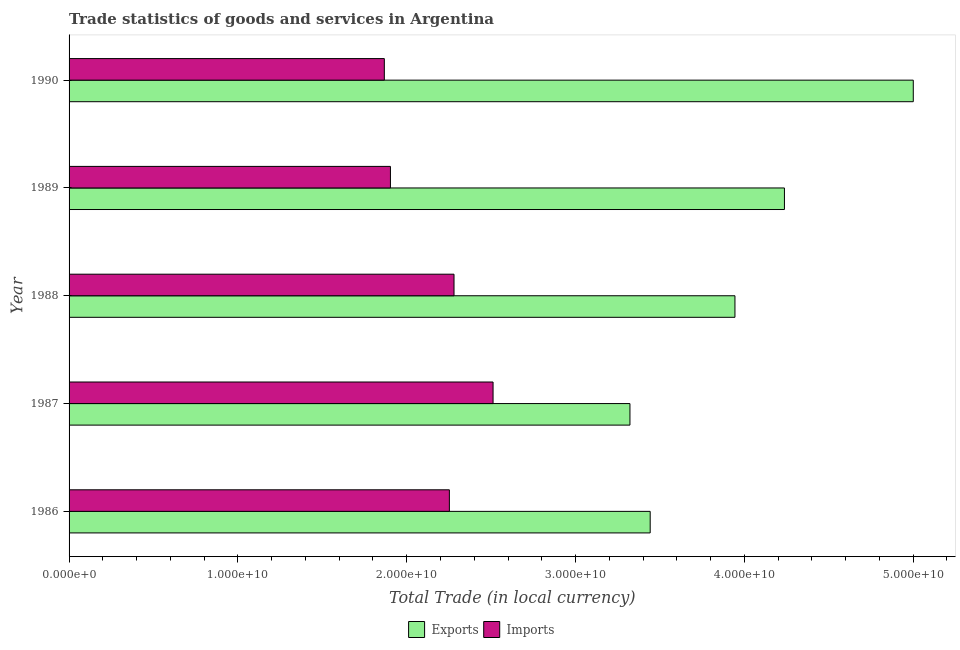How many groups of bars are there?
Provide a succinct answer. 5. Are the number of bars on each tick of the Y-axis equal?
Ensure brevity in your answer.  Yes. What is the export of goods and services in 1990?
Offer a terse response. 5.00e+1. Across all years, what is the maximum imports of goods and services?
Your response must be concise. 2.51e+1. Across all years, what is the minimum export of goods and services?
Your answer should be compact. 3.32e+1. In which year was the imports of goods and services maximum?
Keep it short and to the point. 1987. In which year was the export of goods and services minimum?
Your answer should be very brief. 1987. What is the total export of goods and services in the graph?
Keep it short and to the point. 1.99e+11. What is the difference between the export of goods and services in 1988 and that in 1989?
Your answer should be very brief. -2.93e+09. What is the difference between the export of goods and services in 1989 and the imports of goods and services in 1988?
Offer a terse response. 1.96e+1. What is the average imports of goods and services per year?
Provide a succinct answer. 2.16e+1. In the year 1986, what is the difference between the imports of goods and services and export of goods and services?
Provide a short and direct response. -1.19e+1. What is the ratio of the export of goods and services in 1988 to that in 1990?
Your answer should be very brief. 0.79. What is the difference between the highest and the second highest imports of goods and services?
Provide a short and direct response. 2.31e+09. What is the difference between the highest and the lowest export of goods and services?
Make the answer very short. 1.68e+1. In how many years, is the imports of goods and services greater than the average imports of goods and services taken over all years?
Offer a terse response. 3. Is the sum of the imports of goods and services in 1988 and 1990 greater than the maximum export of goods and services across all years?
Offer a very short reply. No. What does the 2nd bar from the top in 1986 represents?
Make the answer very short. Exports. What does the 1st bar from the bottom in 1986 represents?
Offer a very short reply. Exports. Are all the bars in the graph horizontal?
Your answer should be compact. Yes. Are the values on the major ticks of X-axis written in scientific E-notation?
Your answer should be very brief. Yes. Does the graph contain grids?
Offer a terse response. No. How many legend labels are there?
Your response must be concise. 2. How are the legend labels stacked?
Provide a succinct answer. Horizontal. What is the title of the graph?
Offer a terse response. Trade statistics of goods and services in Argentina. Does "Crop" appear as one of the legend labels in the graph?
Offer a very short reply. No. What is the label or title of the X-axis?
Keep it short and to the point. Total Trade (in local currency). What is the Total Trade (in local currency) of Exports in 1986?
Provide a short and direct response. 3.44e+1. What is the Total Trade (in local currency) of Imports in 1986?
Your answer should be compact. 2.25e+1. What is the Total Trade (in local currency) of Exports in 1987?
Your answer should be very brief. 3.32e+1. What is the Total Trade (in local currency) of Imports in 1987?
Offer a very short reply. 2.51e+1. What is the Total Trade (in local currency) of Exports in 1988?
Provide a short and direct response. 3.94e+1. What is the Total Trade (in local currency) in Imports in 1988?
Your answer should be compact. 2.28e+1. What is the Total Trade (in local currency) in Exports in 1989?
Keep it short and to the point. 4.24e+1. What is the Total Trade (in local currency) of Imports in 1989?
Make the answer very short. 1.90e+1. What is the Total Trade (in local currency) in Exports in 1990?
Provide a short and direct response. 5.00e+1. What is the Total Trade (in local currency) in Imports in 1990?
Your answer should be compact. 1.87e+1. Across all years, what is the maximum Total Trade (in local currency) of Exports?
Ensure brevity in your answer.  5.00e+1. Across all years, what is the maximum Total Trade (in local currency) of Imports?
Keep it short and to the point. 2.51e+1. Across all years, what is the minimum Total Trade (in local currency) in Exports?
Your answer should be compact. 3.32e+1. Across all years, what is the minimum Total Trade (in local currency) of Imports?
Ensure brevity in your answer.  1.87e+1. What is the total Total Trade (in local currency) of Exports in the graph?
Ensure brevity in your answer.  1.99e+11. What is the total Total Trade (in local currency) of Imports in the graph?
Keep it short and to the point. 1.08e+11. What is the difference between the Total Trade (in local currency) in Exports in 1986 and that in 1987?
Provide a short and direct response. 1.20e+09. What is the difference between the Total Trade (in local currency) in Imports in 1986 and that in 1987?
Offer a very short reply. -2.59e+09. What is the difference between the Total Trade (in local currency) of Exports in 1986 and that in 1988?
Your response must be concise. -5.02e+09. What is the difference between the Total Trade (in local currency) of Imports in 1986 and that in 1988?
Give a very brief answer. -2.75e+08. What is the difference between the Total Trade (in local currency) in Exports in 1986 and that in 1989?
Your answer should be compact. -7.95e+09. What is the difference between the Total Trade (in local currency) in Imports in 1986 and that in 1989?
Give a very brief answer. 3.49e+09. What is the difference between the Total Trade (in local currency) of Exports in 1986 and that in 1990?
Keep it short and to the point. -1.56e+1. What is the difference between the Total Trade (in local currency) of Imports in 1986 and that in 1990?
Provide a short and direct response. 3.85e+09. What is the difference between the Total Trade (in local currency) of Exports in 1987 and that in 1988?
Your answer should be very brief. -6.22e+09. What is the difference between the Total Trade (in local currency) of Imports in 1987 and that in 1988?
Your answer should be very brief. 2.31e+09. What is the difference between the Total Trade (in local currency) of Exports in 1987 and that in 1989?
Your answer should be very brief. -9.15e+09. What is the difference between the Total Trade (in local currency) of Imports in 1987 and that in 1989?
Keep it short and to the point. 6.08e+09. What is the difference between the Total Trade (in local currency) of Exports in 1987 and that in 1990?
Your response must be concise. -1.68e+1. What is the difference between the Total Trade (in local currency) of Imports in 1987 and that in 1990?
Ensure brevity in your answer.  6.44e+09. What is the difference between the Total Trade (in local currency) in Exports in 1988 and that in 1989?
Give a very brief answer. -2.93e+09. What is the difference between the Total Trade (in local currency) in Imports in 1988 and that in 1989?
Your response must be concise. 3.77e+09. What is the difference between the Total Trade (in local currency) of Exports in 1988 and that in 1990?
Offer a terse response. -1.06e+1. What is the difference between the Total Trade (in local currency) in Imports in 1988 and that in 1990?
Your answer should be very brief. 4.13e+09. What is the difference between the Total Trade (in local currency) of Exports in 1989 and that in 1990?
Your answer should be very brief. -7.63e+09. What is the difference between the Total Trade (in local currency) of Imports in 1989 and that in 1990?
Provide a succinct answer. 3.62e+08. What is the difference between the Total Trade (in local currency) in Exports in 1986 and the Total Trade (in local currency) in Imports in 1987?
Offer a very short reply. 9.31e+09. What is the difference between the Total Trade (in local currency) in Exports in 1986 and the Total Trade (in local currency) in Imports in 1988?
Provide a short and direct response. 1.16e+1. What is the difference between the Total Trade (in local currency) in Exports in 1986 and the Total Trade (in local currency) in Imports in 1989?
Offer a very short reply. 1.54e+1. What is the difference between the Total Trade (in local currency) in Exports in 1986 and the Total Trade (in local currency) in Imports in 1990?
Keep it short and to the point. 1.57e+1. What is the difference between the Total Trade (in local currency) of Exports in 1987 and the Total Trade (in local currency) of Imports in 1988?
Your answer should be very brief. 1.04e+1. What is the difference between the Total Trade (in local currency) in Exports in 1987 and the Total Trade (in local currency) in Imports in 1989?
Your answer should be compact. 1.42e+1. What is the difference between the Total Trade (in local currency) in Exports in 1987 and the Total Trade (in local currency) in Imports in 1990?
Your response must be concise. 1.45e+1. What is the difference between the Total Trade (in local currency) in Exports in 1988 and the Total Trade (in local currency) in Imports in 1989?
Keep it short and to the point. 2.04e+1. What is the difference between the Total Trade (in local currency) of Exports in 1988 and the Total Trade (in local currency) of Imports in 1990?
Ensure brevity in your answer.  2.08e+1. What is the difference between the Total Trade (in local currency) in Exports in 1989 and the Total Trade (in local currency) in Imports in 1990?
Keep it short and to the point. 2.37e+1. What is the average Total Trade (in local currency) in Exports per year?
Ensure brevity in your answer.  3.99e+1. What is the average Total Trade (in local currency) of Imports per year?
Keep it short and to the point. 2.16e+1. In the year 1986, what is the difference between the Total Trade (in local currency) in Exports and Total Trade (in local currency) in Imports?
Offer a very short reply. 1.19e+1. In the year 1987, what is the difference between the Total Trade (in local currency) of Exports and Total Trade (in local currency) of Imports?
Your answer should be very brief. 8.11e+09. In the year 1988, what is the difference between the Total Trade (in local currency) in Exports and Total Trade (in local currency) in Imports?
Provide a succinct answer. 1.66e+1. In the year 1989, what is the difference between the Total Trade (in local currency) in Exports and Total Trade (in local currency) in Imports?
Your answer should be compact. 2.33e+1. In the year 1990, what is the difference between the Total Trade (in local currency) of Exports and Total Trade (in local currency) of Imports?
Your answer should be very brief. 3.13e+1. What is the ratio of the Total Trade (in local currency) of Exports in 1986 to that in 1987?
Offer a terse response. 1.04. What is the ratio of the Total Trade (in local currency) in Imports in 1986 to that in 1987?
Give a very brief answer. 0.9. What is the ratio of the Total Trade (in local currency) of Exports in 1986 to that in 1988?
Offer a very short reply. 0.87. What is the ratio of the Total Trade (in local currency) in Imports in 1986 to that in 1988?
Ensure brevity in your answer.  0.99. What is the ratio of the Total Trade (in local currency) of Exports in 1986 to that in 1989?
Your answer should be very brief. 0.81. What is the ratio of the Total Trade (in local currency) of Imports in 1986 to that in 1989?
Your answer should be very brief. 1.18. What is the ratio of the Total Trade (in local currency) in Exports in 1986 to that in 1990?
Ensure brevity in your answer.  0.69. What is the ratio of the Total Trade (in local currency) in Imports in 1986 to that in 1990?
Provide a short and direct response. 1.21. What is the ratio of the Total Trade (in local currency) of Exports in 1987 to that in 1988?
Provide a succinct answer. 0.84. What is the ratio of the Total Trade (in local currency) of Imports in 1987 to that in 1988?
Offer a very short reply. 1.1. What is the ratio of the Total Trade (in local currency) of Exports in 1987 to that in 1989?
Your response must be concise. 0.78. What is the ratio of the Total Trade (in local currency) of Imports in 1987 to that in 1989?
Ensure brevity in your answer.  1.32. What is the ratio of the Total Trade (in local currency) in Exports in 1987 to that in 1990?
Your response must be concise. 0.66. What is the ratio of the Total Trade (in local currency) of Imports in 1987 to that in 1990?
Offer a terse response. 1.34. What is the ratio of the Total Trade (in local currency) of Exports in 1988 to that in 1989?
Ensure brevity in your answer.  0.93. What is the ratio of the Total Trade (in local currency) of Imports in 1988 to that in 1989?
Make the answer very short. 1.2. What is the ratio of the Total Trade (in local currency) in Exports in 1988 to that in 1990?
Your response must be concise. 0.79. What is the ratio of the Total Trade (in local currency) in Imports in 1988 to that in 1990?
Your answer should be very brief. 1.22. What is the ratio of the Total Trade (in local currency) in Exports in 1989 to that in 1990?
Ensure brevity in your answer.  0.85. What is the ratio of the Total Trade (in local currency) in Imports in 1989 to that in 1990?
Your answer should be very brief. 1.02. What is the difference between the highest and the second highest Total Trade (in local currency) in Exports?
Offer a very short reply. 7.63e+09. What is the difference between the highest and the second highest Total Trade (in local currency) in Imports?
Provide a succinct answer. 2.31e+09. What is the difference between the highest and the lowest Total Trade (in local currency) in Exports?
Offer a terse response. 1.68e+1. What is the difference between the highest and the lowest Total Trade (in local currency) of Imports?
Make the answer very short. 6.44e+09. 